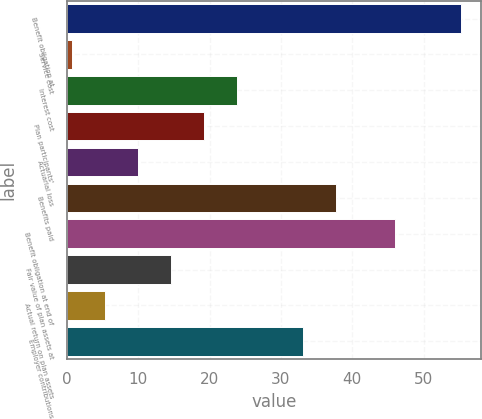Convert chart to OTSL. <chart><loc_0><loc_0><loc_500><loc_500><bar_chart><fcel>Benefit obligation at<fcel>Service cost<fcel>Interest cost<fcel>Plan participants'<fcel>Actuarial loss<fcel>Benefits paid<fcel>Benefit obligation at end of<fcel>Fair value of plan assets at<fcel>Actual return on plan assets<fcel>Employer contributions<nl><fcel>55.24<fcel>0.76<fcel>23.86<fcel>19.24<fcel>10<fcel>37.72<fcel>46<fcel>14.62<fcel>5.38<fcel>33.1<nl></chart> 